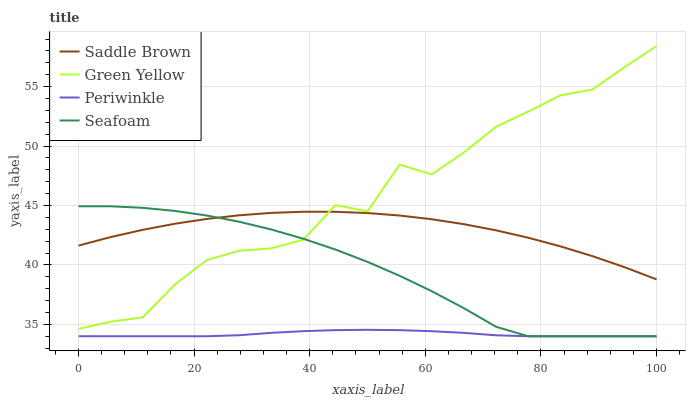Does Periwinkle have the minimum area under the curve?
Answer yes or no. Yes. Does Green Yellow have the maximum area under the curve?
Answer yes or no. Yes. Does Saddle Brown have the minimum area under the curve?
Answer yes or no. No. Does Saddle Brown have the maximum area under the curve?
Answer yes or no. No. Is Periwinkle the smoothest?
Answer yes or no. Yes. Is Green Yellow the roughest?
Answer yes or no. Yes. Is Saddle Brown the smoothest?
Answer yes or no. No. Is Saddle Brown the roughest?
Answer yes or no. No. Does Periwinkle have the lowest value?
Answer yes or no. Yes. Does Saddle Brown have the lowest value?
Answer yes or no. No. Does Green Yellow have the highest value?
Answer yes or no. Yes. Does Saddle Brown have the highest value?
Answer yes or no. No. Is Periwinkle less than Saddle Brown?
Answer yes or no. Yes. Is Green Yellow greater than Periwinkle?
Answer yes or no. Yes. Does Saddle Brown intersect Seafoam?
Answer yes or no. Yes. Is Saddle Brown less than Seafoam?
Answer yes or no. No. Is Saddle Brown greater than Seafoam?
Answer yes or no. No. Does Periwinkle intersect Saddle Brown?
Answer yes or no. No. 